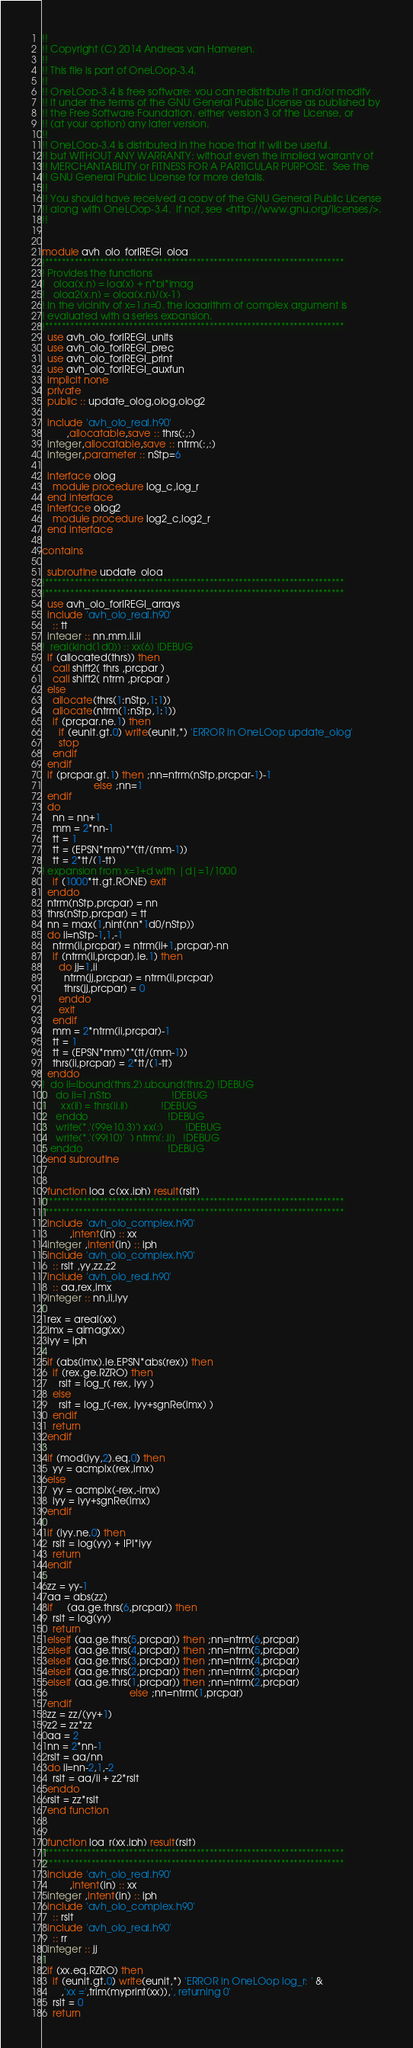Convert code to text. <code><loc_0><loc_0><loc_500><loc_500><_FORTRAN_>!!
!! Copyright (C) 2014 Andreas van Hameren. 
!!
!! This file is part of OneLOop-3.4.
!!
!! OneLOop-3.4 is free software: you can redistribute it and/or modify
!! it under the terms of the GNU General Public License as published by
!! the Free Software Foundation, either version 3 of the License, or
!! (at your option) any later version.
!!
!! OneLOop-3.4 is distributed in the hope that it will be useful,
!! but WITHOUT ANY WARRANTY; without even the implied warranty of
!! MERCHANTABILITY or FITNESS FOR A PARTICULAR PURPOSE.  See the
!! GNU General Public License for more details.
!!
!! You should have received a copy of the GNU General Public License
!! along with OneLOop-3.4.  If not, see <http://www.gnu.org/licenses/>.
!!


module avh_olo_forIREGI_olog
!***********************************************************************
! Provides the functions
!   olog(x,n) = log(x) + n*pi*imag  
!   olog2(x,n) = olog(x,n)/(x-1)
! In the vicinity of x=1,n=0, the logarithm of complex argument is
! evaluated with a series expansion.
!***********************************************************************
  use avh_olo_forIREGI_units
  use avh_olo_forIREGI_prec
  use avh_olo_forIREGI_print
  use avh_olo_forIREGI_auxfun
  implicit none
  private
  public :: update_olog,olog,olog2

  include 'avh_olo_real.h90'
         ,allocatable,save :: thrs(:,:)
  integer,allocatable,save :: ntrm(:,:)
  integer,parameter :: nStp=6

  interface olog
    module procedure log_c,log_r
  end interface
  interface olog2
    module procedure log2_c,log2_r
  end interface

contains

  subroutine update_olog
!***********************************************************************
!***********************************************************************
  use avh_olo_forIREGI_arrays
  include 'avh_olo_real.h90'
    :: tt
  integer :: nn,mm,ii,jj
!  real(kind(1d0)) :: xx(6) !DEBUG
  if (allocated(thrs)) then
    call shift2( thrs ,prcpar )
    call shift2( ntrm ,prcpar )
  else
    allocate(thrs(1:nStp,1:1))
    allocate(ntrm(1:nStp,1:1))
    if (prcpar.ne.1) then
      if (eunit.gt.0) write(eunit,*) 'ERROR in OneLOop update_olog'
      stop
    endif
  endif
  if (prcpar.gt.1) then ;nn=ntrm(nStp,prcpar-1)-1
                   else ;nn=1
  endif
  do
    nn = nn+1
    mm = 2*nn-1
    tt = 1
    tt = (EPSN*mm)**(tt/(mm-1))
    tt = 2*tt/(1-tt)
! expansion from x=1+d with |d|=1/1000
    if (1000*tt.gt.RONE) exit
  enddo
  ntrm(nStp,prcpar) = nn
  thrs(nStp,prcpar) = tt
  nn = max(1,nint(nn*1d0/nStp))
  do ii=nStp-1,1,-1
    ntrm(ii,prcpar) = ntrm(ii+1,prcpar)-nn
    if (ntrm(ii,prcpar).le.1) then
      do jj=1,ii
        ntrm(jj,prcpar) = ntrm(ii,prcpar)
        thrs(jj,prcpar) = 0 
      enddo
      exit
    endif
    mm = 2*ntrm(ii,prcpar)-1
    tt = 1
    tt = (EPSN*mm)**(tt/(mm-1))
    thrs(ii,prcpar) = 2*tt/(1-tt)
  enddo
!  do ii=lbound(thrs,2),ubound(thrs,2) !DEBUG
!    do jj=1,nStp                      !DEBUG
!      xx(jj) = thrs(jj,ii)            !DEBUG
!    enddo                             !DEBUG
!    write(*,'(99e10.3)') xx(:)        !DEBUG
!    write(*,'(99i10)'  ) ntrm(:,ii)   !DEBUG
!  enddo                               !DEBUG
  end subroutine


  function log_c(xx,iph) result(rslt)
!***********************************************************************
!***********************************************************************
  include 'avh_olo_complex.h90'
          ,intent(in) :: xx
  integer ,intent(in) :: iph
  include 'avh_olo_complex.h90'
    :: rslt ,yy,zz,z2
  include 'avh_olo_real.h90'
    :: aa,rex,imx
  integer :: nn,ii,iyy
!
  rex = areal(xx)
  imx = aimag(xx)
  iyy = iph
!
  if (abs(imx).le.EPSN*abs(rex)) then
    if (rex.ge.RZRO) then
      rslt = log_r( rex, iyy )
    else
      rslt = log_r(-rex, iyy+sgnRe(imx) )
    endif
    return
  endif
!
  if (mod(iyy,2).eq.0) then
    yy = acmplx(rex,imx)
  else
    yy = acmplx(-rex,-imx)
    iyy = iyy+sgnRe(imx)
  endif
!
  if (iyy.ne.0) then
    rslt = log(yy) + IPI*iyy
    return
  endif
!
  zz = yy-1
  aa = abs(zz)
  if     (aa.ge.thrs(6,prcpar)) then
    rslt = log(yy)
    return
  elseif (aa.ge.thrs(5,prcpar)) then ;nn=ntrm(6,prcpar)
  elseif (aa.ge.thrs(4,prcpar)) then ;nn=ntrm(5,prcpar)
  elseif (aa.ge.thrs(3,prcpar)) then ;nn=ntrm(4,prcpar)
  elseif (aa.ge.thrs(2,prcpar)) then ;nn=ntrm(3,prcpar)
  elseif (aa.ge.thrs(1,prcpar)) then ;nn=ntrm(2,prcpar)
                                else ;nn=ntrm(1,prcpar)
  endif
  zz = zz/(yy+1)
  z2 = zz*zz
  aa = 2
  nn = 2*nn-1
  rslt = aa/nn
  do ii=nn-2,1,-2
    rslt = aa/ii + z2*rslt
  enddo
  rslt = zz*rslt
  end function


  function log_r(xx,iph) result(rslt)
!***********************************************************************
!***********************************************************************
  include 'avh_olo_real.h90'
          ,intent(in) :: xx
  integer ,intent(in) :: iph
  include 'avh_olo_complex.h90'
    :: rslt
  include 'avh_olo_real.h90'
    :: rr
  integer :: jj
!
  if (xx.eq.RZRO) then
    if (eunit.gt.0) write(eunit,*) 'ERROR in OneLOop log_r: ' &
       ,'xx =',trim(myprint(xx)),', returning 0'
    rslt = 0
    return</code> 